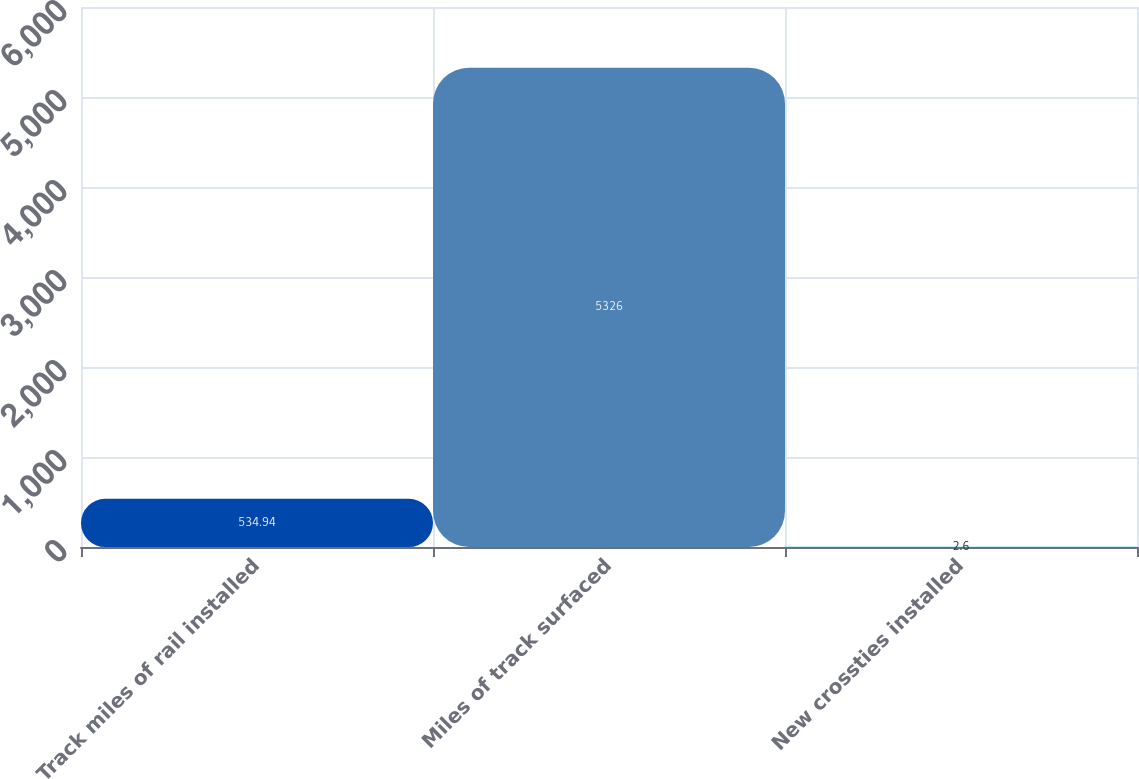Convert chart. <chart><loc_0><loc_0><loc_500><loc_500><bar_chart><fcel>Track miles of rail installed<fcel>Miles of track surfaced<fcel>New crossties installed<nl><fcel>534.94<fcel>5326<fcel>2.6<nl></chart> 